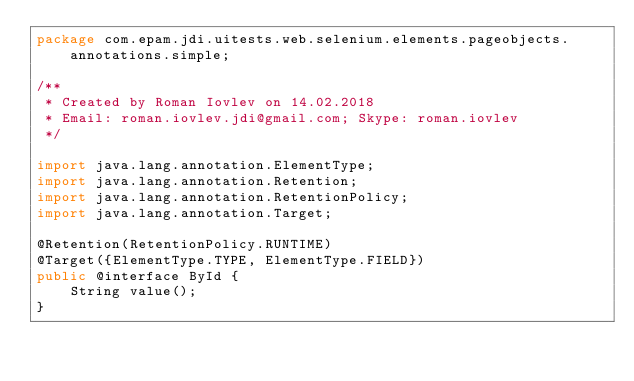Convert code to text. <code><loc_0><loc_0><loc_500><loc_500><_Java_>package com.epam.jdi.uitests.web.selenium.elements.pageobjects.annotations.simple;

/**
 * Created by Roman Iovlev on 14.02.2018
 * Email: roman.iovlev.jdi@gmail.com; Skype: roman.iovlev
 */

import java.lang.annotation.ElementType;
import java.lang.annotation.Retention;
import java.lang.annotation.RetentionPolicy;
import java.lang.annotation.Target;

@Retention(RetentionPolicy.RUNTIME)
@Target({ElementType.TYPE, ElementType.FIELD})
public @interface ById {
    String value();
}
</code> 